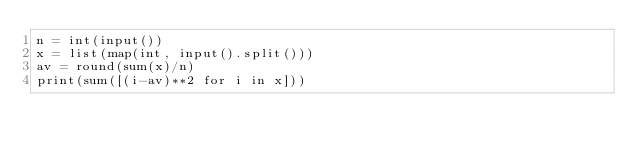<code> <loc_0><loc_0><loc_500><loc_500><_Python_>n = int(input())
x = list(map(int, input().split()))
av = round(sum(x)/n)
print(sum([(i-av)**2 for i in x]))</code> 